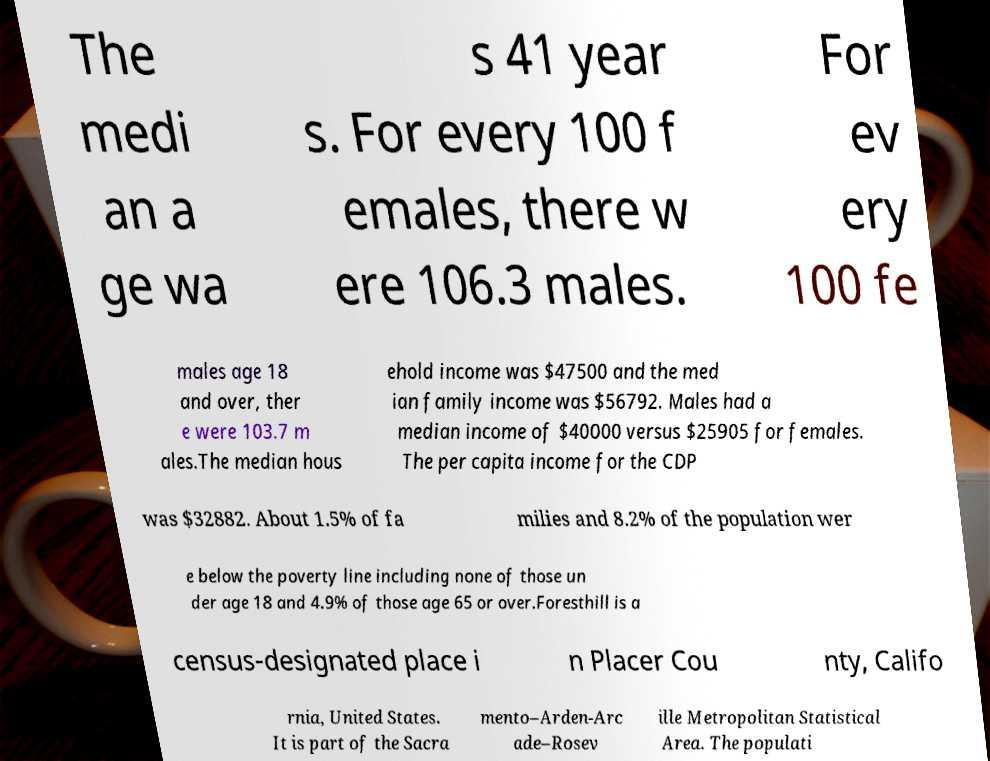Could you assist in decoding the text presented in this image and type it out clearly? The medi an a ge wa s 41 year s. For every 100 f emales, there w ere 106.3 males. For ev ery 100 fe males age 18 and over, ther e were 103.7 m ales.The median hous ehold income was $47500 and the med ian family income was $56792. Males had a median income of $40000 versus $25905 for females. The per capita income for the CDP was $32882. About 1.5% of fa milies and 8.2% of the population wer e below the poverty line including none of those un der age 18 and 4.9% of those age 65 or over.Foresthill is a census-designated place i n Placer Cou nty, Califo rnia, United States. It is part of the Sacra mento–Arden-Arc ade–Rosev ille Metropolitan Statistical Area. The populati 